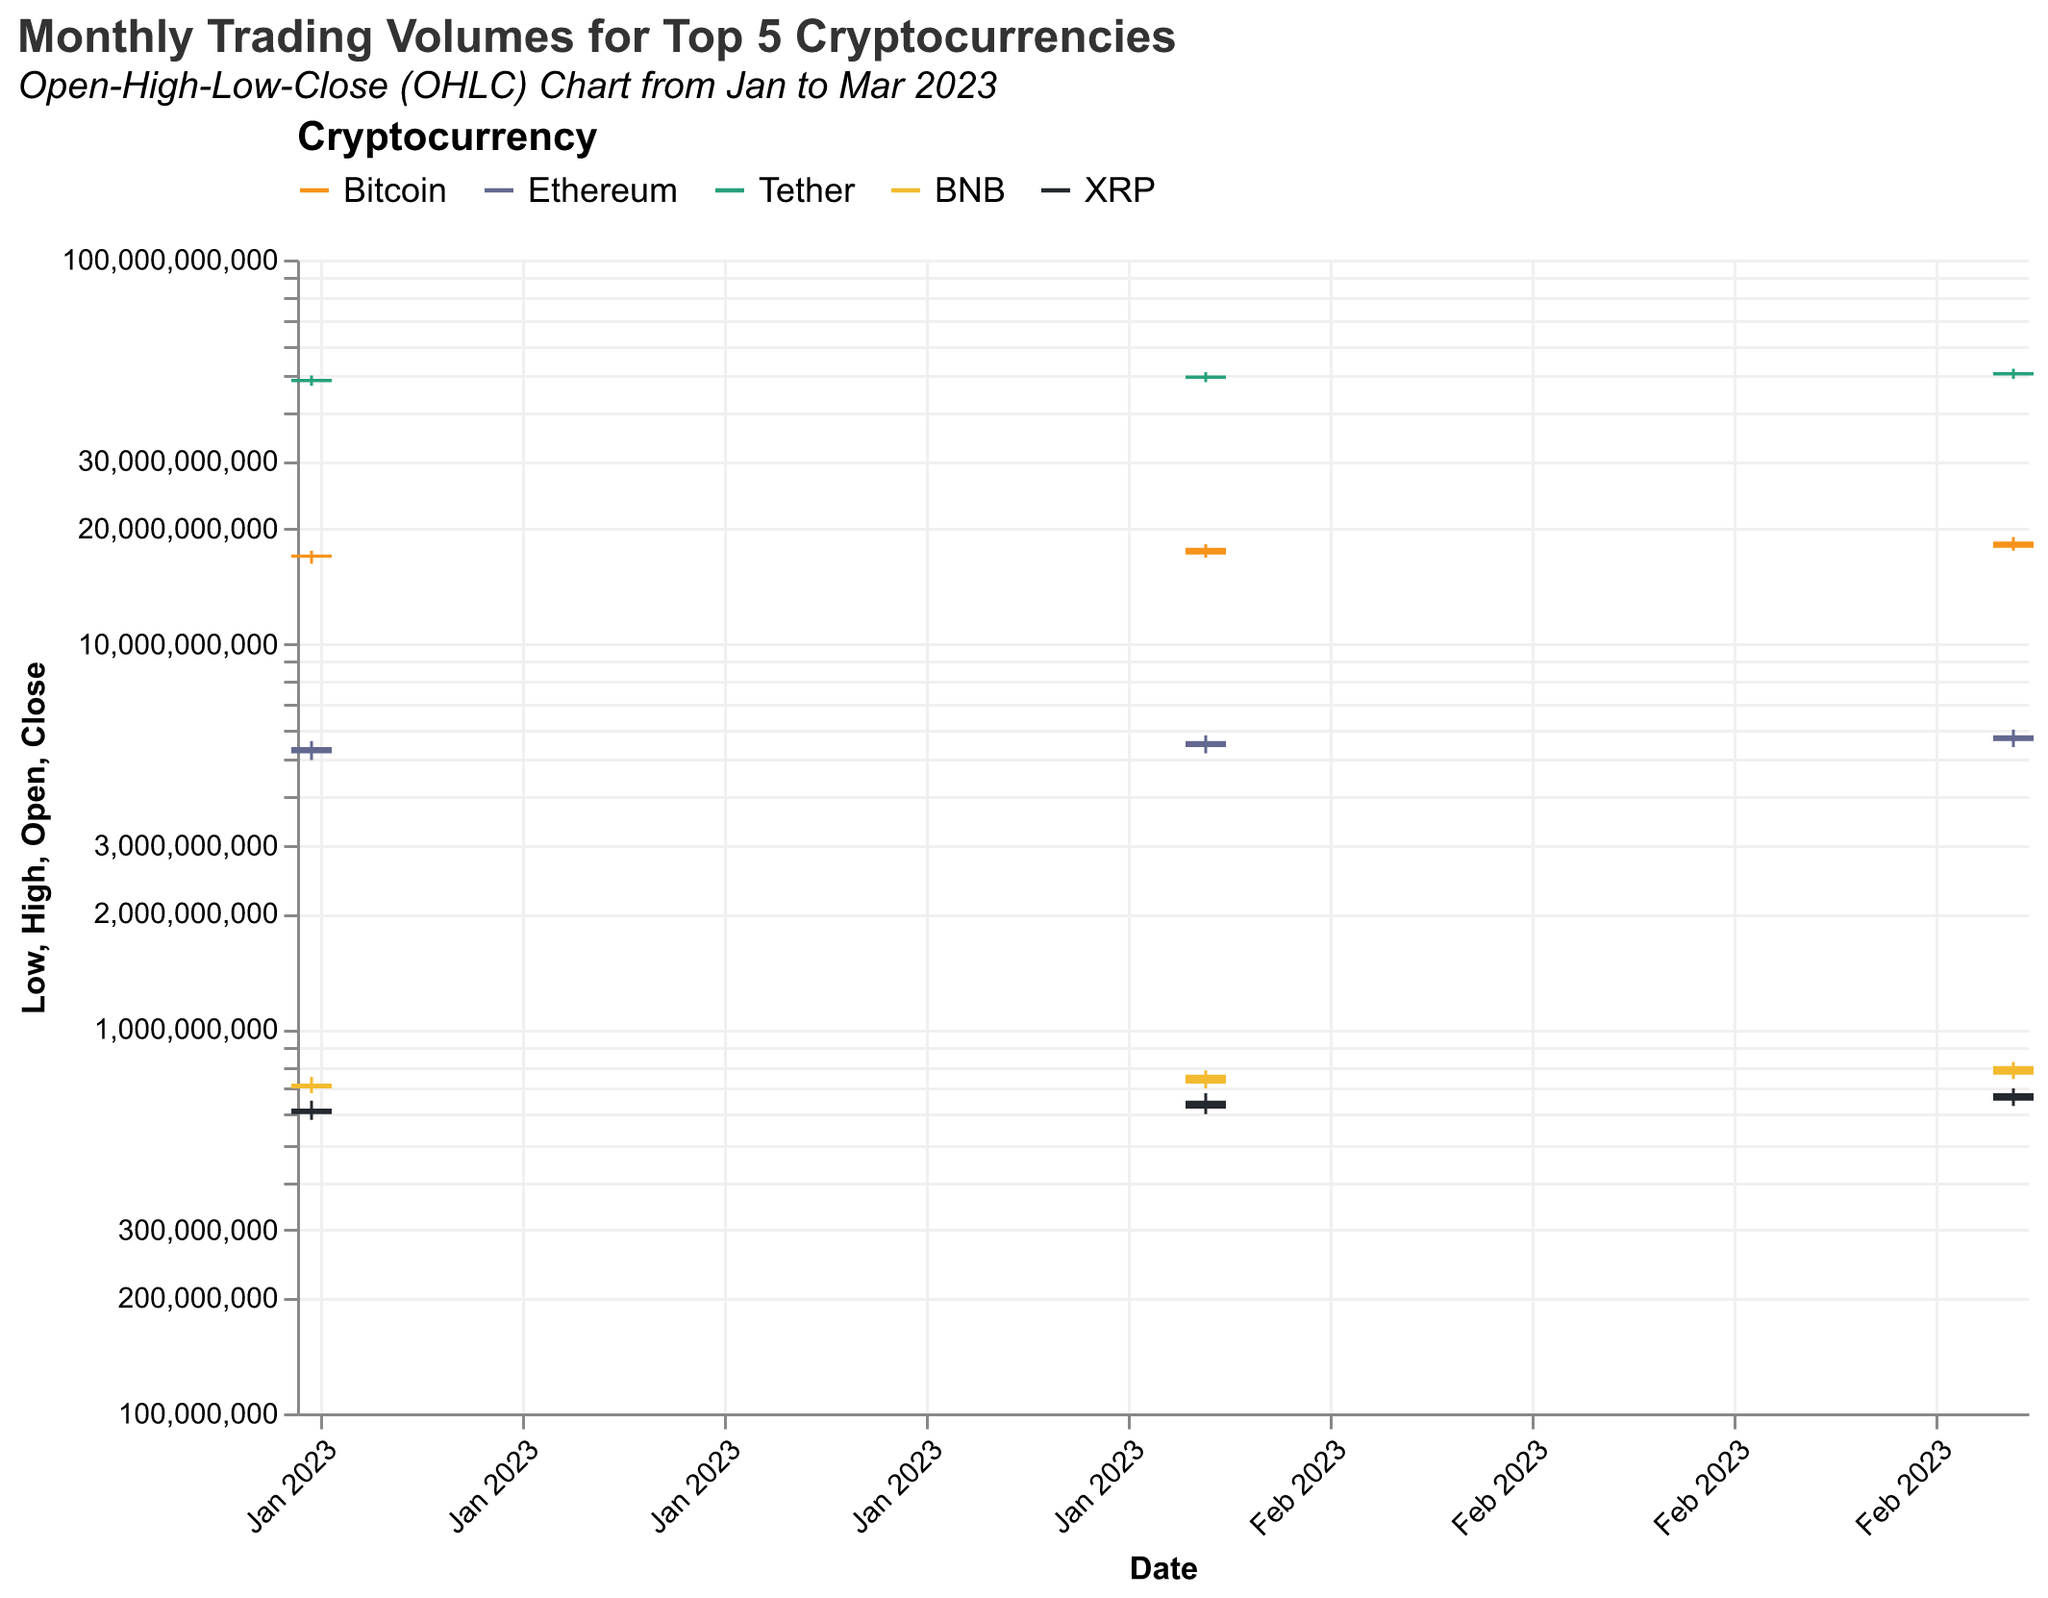What's the title of the figure? The title is usually located at the top of the chart. By looking at this chart, the title mentioned is "Monthly Trading Volumes for Top 5 Cryptocurrencies".
Answer: Monthly Trading Volumes for Top 5 Cryptocurrencies How many time points are displayed in the chart? The chart shows data points based on the date axis, which spans from January 2023 to March 2023. Therefore, there are three time points displayed.
Answer: 3 Which cryptocurrency had the highest trading volume in January 2023? To find this, look at the "High" value for each cryptocurrency in January 2023. Tether had the highest value among the cryptocurrencies with 50,000,000,000.
Answer: Tether How did Bitcoin's closing volume change from January to February 2023? Check Bitcoin's "Close" values for January and February. In January, it was 17,100,000,000, and in February, it was 17,800,000,000. The change is calculated as 17,800,000,000 - 17,100,000,000 = 700,000,000.
Answer: Increased by 700,000,000 Which cryptocurrency showed the greatest increase in its closing volume from January to March 2023? To determine this, find the "Close" value for each cryptocurrency for January and March. Calculate the difference for each and compare. Bitcoin's closing volume increased from 17,100,000,000 in January to 18,500,000,000 in March, the largest increase among the top 5.
Answer: Bitcoin In March 2023, for which cryptocurrency was the range between the highest and the lowest trading volumes the smallest? Calculate the range (High - Low) for each cryptocurrency in March. Comparing these ranges, Tether has the smallest range: 52,000,000,000 - 49,000,000,000 = 3,000,000,000.
Answer: Tether What is the average closing volume for Ethereum over the three months displayed? Add Ethereum's "Close" values for each month and divide by the number of months. (5,400,000,000 + 5,600,000,000 + 5,800,000,000) / 3 = 5,600,000,000.
Answer: 5,600,000,000 Which month did XRP have the largest difference between its opening and closing volumes? Find the differences (Open - Close) for each month and compare. In January, the difference is 600,000,000 - 620,000,000 = -20,000,000. In February, it's 620,000,000 - 650,000,000 = -30,000,000. In March, it's 650,000,000 - 680,000,000 = -30,000,000. The largest difference is equal in February and March, both -30,000,000.
Answer: February and March (equal) Which cryptocurrency had the most stable trading volumes in January 2023 based on the difference between its highest and lowest volumes? Calculate the range (High - Low) for each cryptocurrency. The smallest range indicates the most stable. For January, BNB has the smallest range: 750,000,000 - 680,000,000 = 70,000,000.
Answer: BNB Which cryptocurrency's trading volume was more volatile in February 2023, Bitcoin or Ethereum? Compare the range (High - Low) for both Bitcoin and Ethereum in February. Bitcoin's range is 18,200,000,000 - 16,800,000,000 = 1,400,000,000, while Ethereum's is 5,800,000,000 - 5,200,000,000 = 600,000,000. Bitcoin is more volatile as its range is larger.
Answer: Bitcoin 